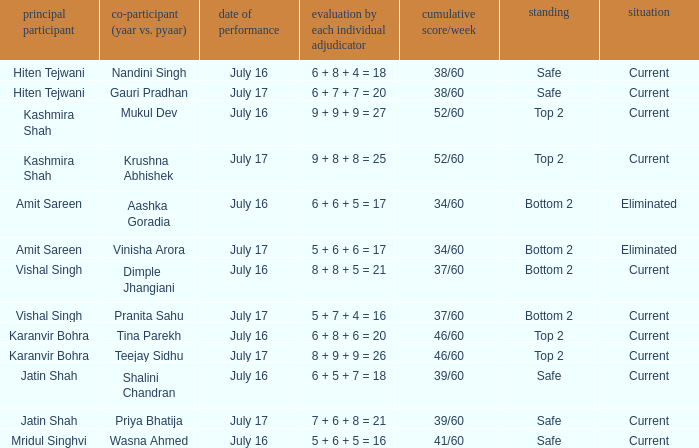What date did Jatin Shah and Shalini Chandran perform? July 16. 